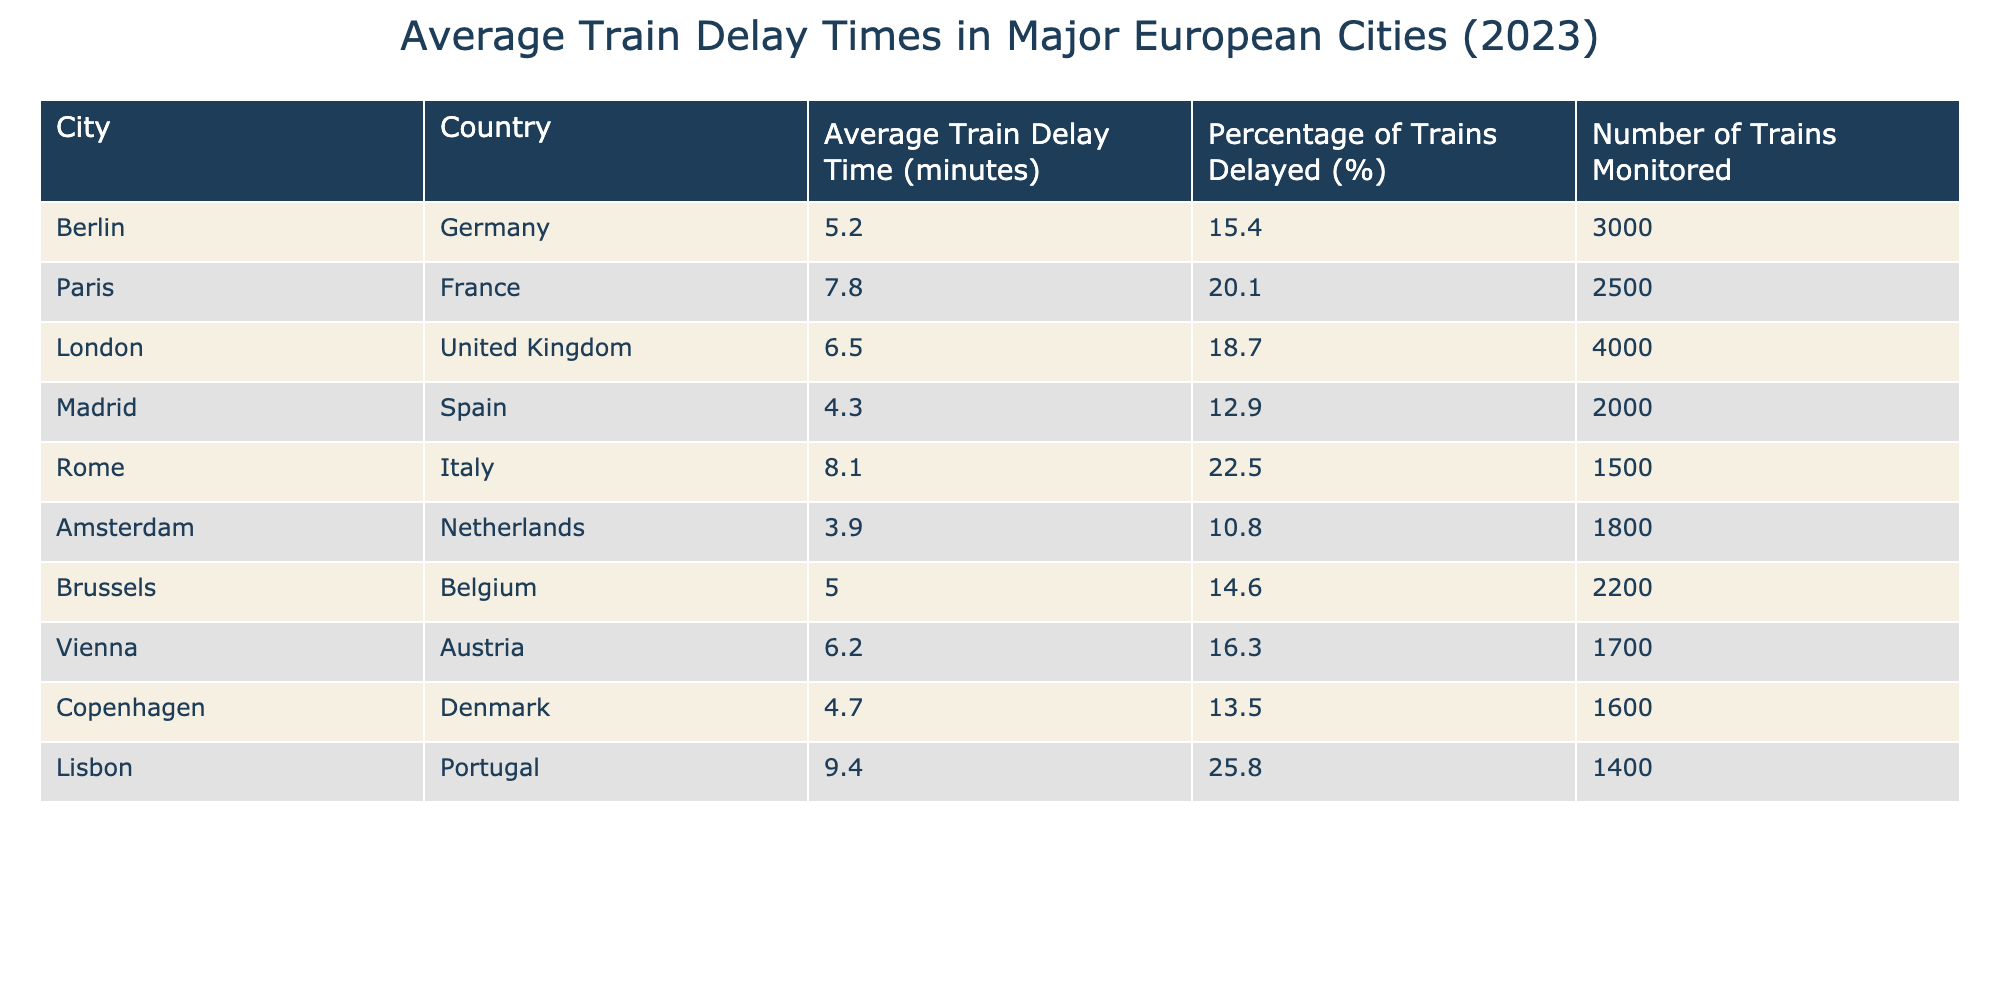What is the average train delay time in Rome? The average train delay time in Rome is listed directly in the table under the column "Average Train Delay Time (minutes)" for the row corresponding to Rome. The value is 8.1 minutes.
Answer: 8.1 minutes Which city has the highest percentage of delayed trains? To find the city with the highest percentage of delayed trains, we can look at the "Percentage of Trains Delayed (%)" column and identify the maximum value. Lisbon has the highest percentage at 25.8%.
Answer: Lisbon What is the average train delay time for the cities monitored? To find the average train delay time, we sum the average delay times of all cities: (5.2 + 7.8 + 6.5 + 4.3 + 8.1 + 3.9 + 5.0 + 6.2 + 4.7 + 9.4) = 61.1 minutes, and then divide by the number of cities (10): 61.1 / 10 = 6.11 minutes.
Answer: 6.11 minutes Is the average train delay time in Paris greater than that of Berlin? By comparing the values in the table, the average train delay time in Paris is 7.8 minutes, while in Berlin, it is 5.2 minutes. Since 7.8 minutes is greater than 5.2 minutes, the statement is true.
Answer: Yes Which city has a lower average train delay time than Brussels? To answer this, we first find the average delay time in Brussels, which is 5.0 minutes. Now, we check each city's average and see which are less than 5.0 minutes: Amsterdam (3.9), and Madrid (4.3) are both less than 5.0 minutes.
Answer: Amsterdam, Madrid What is the total number of trains monitored across all cities? To find this total, we sum the "Number of Trains Monitored" for each city: (3000 + 2500 + 4000 + 2000 + 1500 + 1800 + 2200 + 1700 + 1600 + 1400) = 18800 trains.
Answer: 18800 trains Is the percentage of delayed trains in London greater than both Berlin and Copenhagen? The percentage of delayed trains in London is 18.7%, Berlin is 15.4%, and Copenhagen is 13.5%. Since 18.7% is greater than both 15.4% and 13.5%, the statement is true.
Answer: Yes How does the average train delay time in Amsterdam compare to that in Rome? The average train delay time in Amsterdam is 3.9 minutes, and in Rome, it is 8.1 minutes. Since 3.9 minutes is less than 8.1 minutes, we conclude that Amsterdam has a shorter average delay time than Rome.
Answer: Shorter What is the difference in average train delay time between Lisbon and Madrid? The average train delay time in Lisbon is 9.4 minutes and in Madrid, it is 4.3 minutes. The difference is 9.4 - 4.3 = 5.1 minutes, indicating that Lisbon has a longer delay time by this amount.
Answer: 5.1 minutes 